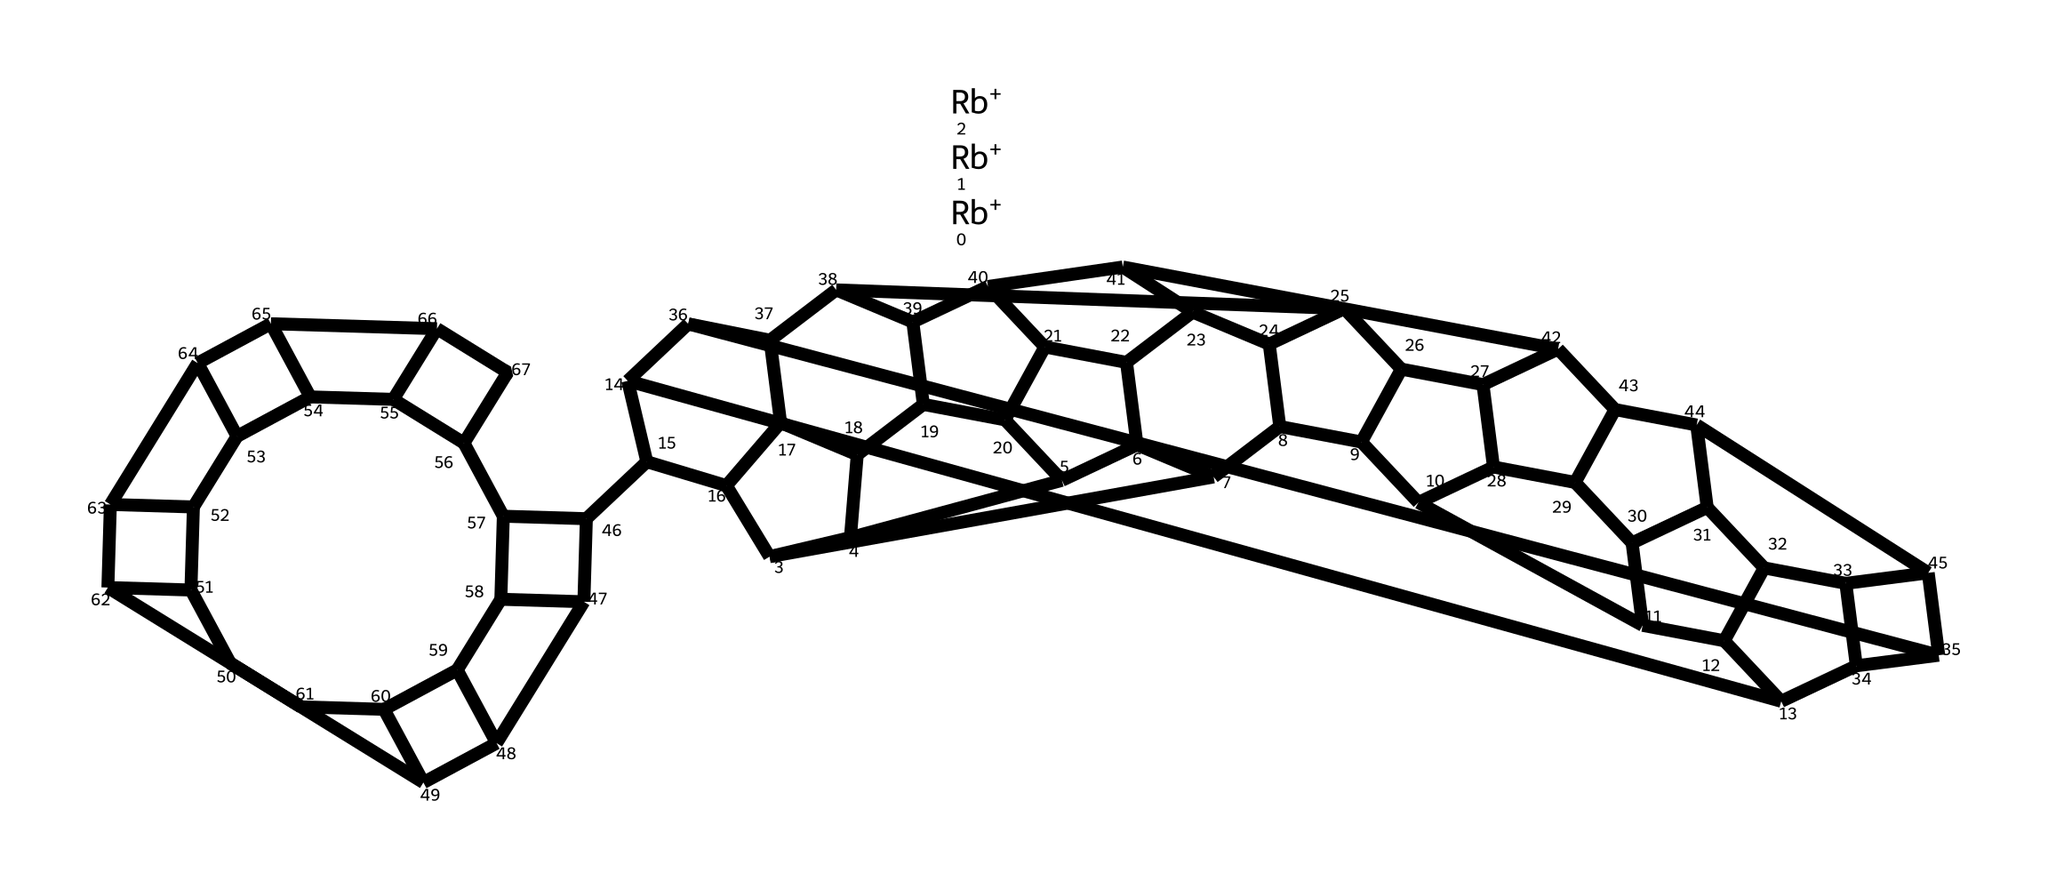What is the central atom in rubidium fulleride? The central atom in rubidium fulleride is carbon, as indicated by the 'C' in the SMILES structure and the presence of carbon atoms in the fullerene cage.
Answer: carbon How many rubidium atoms are present in this molecule? The SMILES structure starts with three 'Rb+' symbols, indicating that there are three rubidium atoms in rubidium fulleride.
Answer: three What type of hybridization is expected at the carbon atoms in the C60 structure? In the C60 structure, the carbon atoms are typically sp2 hybridized due to their arrangement within the hexagonal and pentagonal faces of the fullerene.
Answer: sp2 Is rubidium fulleride a conductor or an insulator? Rubidium fulleride is typically a conductor as it can donate electrons due to the presence of the rubidium ions, which facilitate conductivity in the structure.
Answer: conductor What molecular geometry does the fullerene C60 have? The molecular geometry of C60 is generally described as a truncated icosahedron, which is characteristic of the fullerene family of molecules.
Answer: truncated icosahedron How many total carbon atoms are in the C60 molecule? The structure of C60 specifically indicates a complete fullerene molecule containing 60 carbon atoms arranged in a spherical shape.
Answer: sixty What role do the rubidium ions play in the structure of rubidium fulleride? The rubidium ions act as electron donors, which stabilize the fullerene cage and contribute to its conductivity by doping the carbon network.
Answer: electron donors 